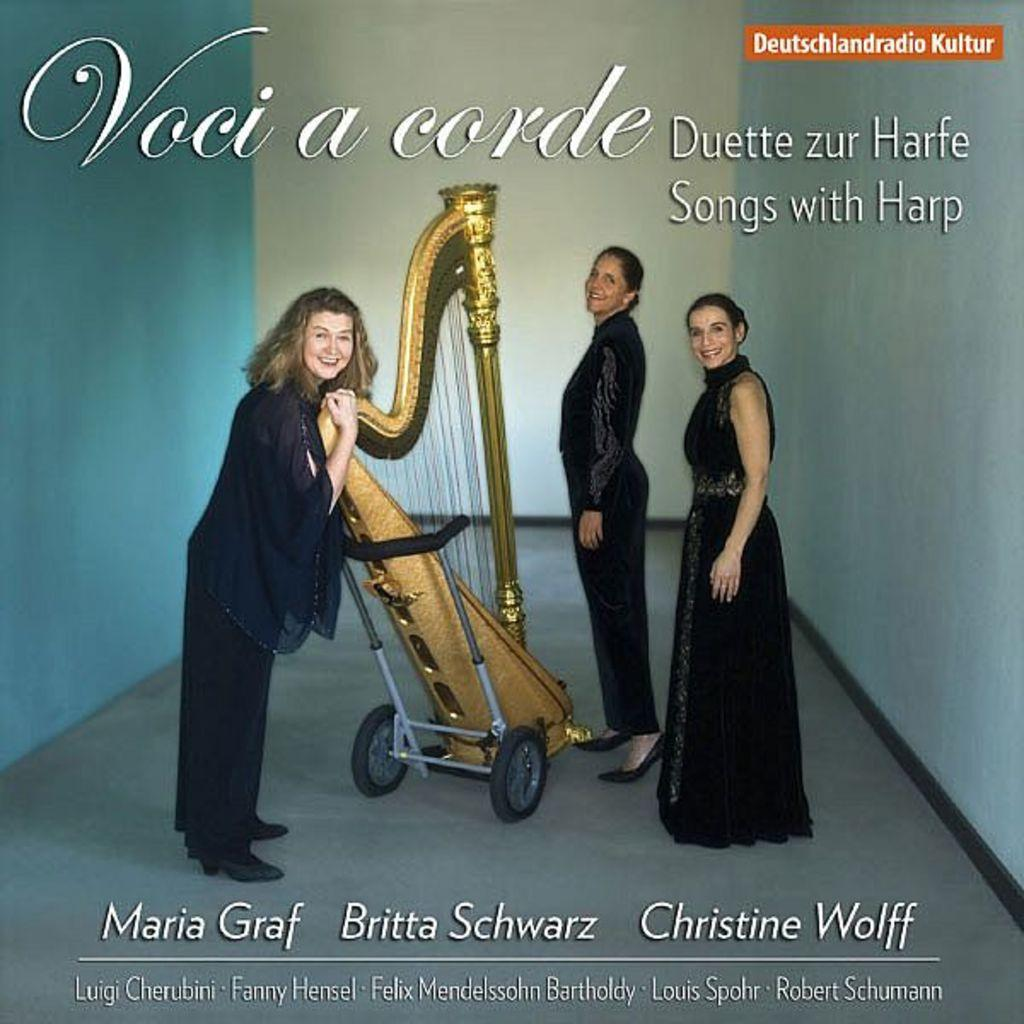What object is on a trolley in the image? There is a musical instrument on a trolley in the image. Can you describe the people in the image? There are people in the image, but their specific actions or appearances are not mentioned in the provided facts. What can be seen in the background of the image? There is a wall and text visible in the background of the image. What type of shoe is the person wearing in the image? There is no information about shoes or the appearance of the people in the image, so we cannot answer this question. 